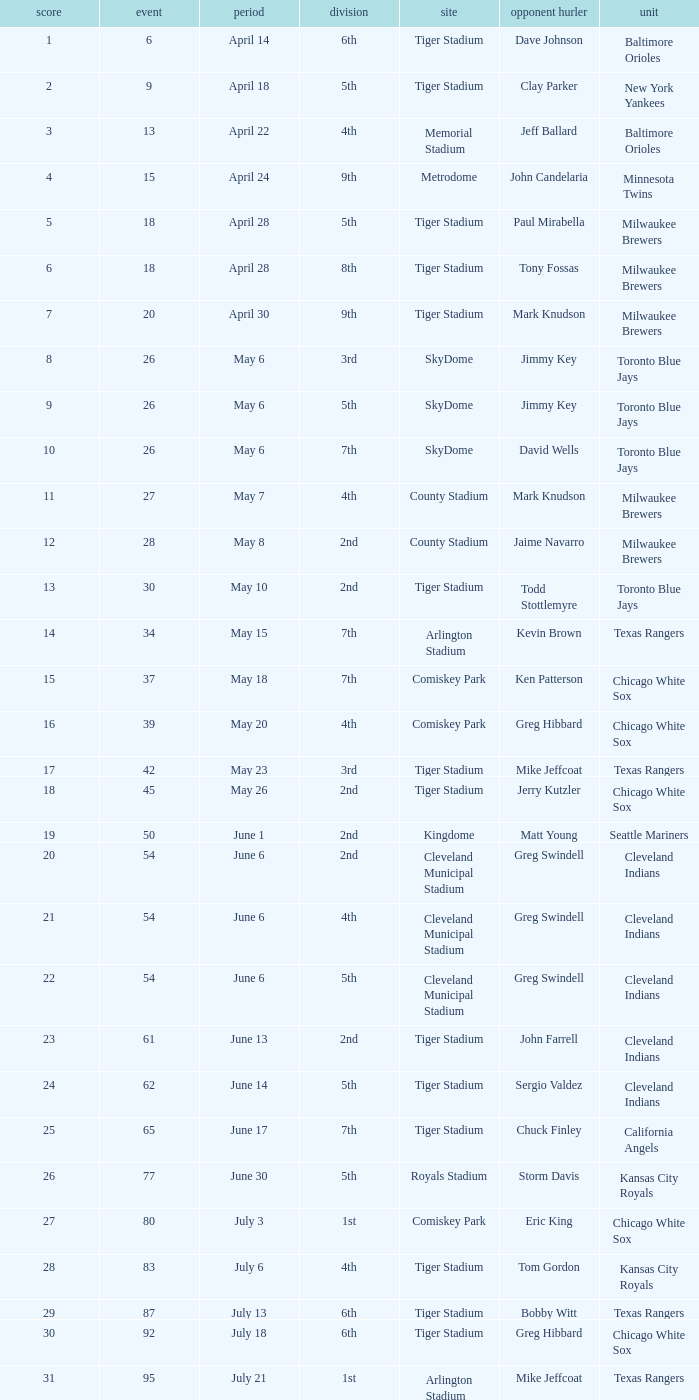Would you be able to parse every entry in this table? {'header': ['score', 'event', 'period', 'division', 'site', 'opponent hurler', 'unit'], 'rows': [['1', '6', 'April 14', '6th', 'Tiger Stadium', 'Dave Johnson', 'Baltimore Orioles'], ['2', '9', 'April 18', '5th', 'Tiger Stadium', 'Clay Parker', 'New York Yankees'], ['3', '13', 'April 22', '4th', 'Memorial Stadium', 'Jeff Ballard', 'Baltimore Orioles'], ['4', '15', 'April 24', '9th', 'Metrodome', 'John Candelaria', 'Minnesota Twins'], ['5', '18', 'April 28', '5th', 'Tiger Stadium', 'Paul Mirabella', 'Milwaukee Brewers'], ['6', '18', 'April 28', '8th', 'Tiger Stadium', 'Tony Fossas', 'Milwaukee Brewers'], ['7', '20', 'April 30', '9th', 'Tiger Stadium', 'Mark Knudson', 'Milwaukee Brewers'], ['8', '26', 'May 6', '3rd', 'SkyDome', 'Jimmy Key', 'Toronto Blue Jays'], ['9', '26', 'May 6', '5th', 'SkyDome', 'Jimmy Key', 'Toronto Blue Jays'], ['10', '26', 'May 6', '7th', 'SkyDome', 'David Wells', 'Toronto Blue Jays'], ['11', '27', 'May 7', '4th', 'County Stadium', 'Mark Knudson', 'Milwaukee Brewers'], ['12', '28', 'May 8', '2nd', 'County Stadium', 'Jaime Navarro', 'Milwaukee Brewers'], ['13', '30', 'May 10', '2nd', 'Tiger Stadium', 'Todd Stottlemyre', 'Toronto Blue Jays'], ['14', '34', 'May 15', '7th', 'Arlington Stadium', 'Kevin Brown', 'Texas Rangers'], ['15', '37', 'May 18', '7th', 'Comiskey Park', 'Ken Patterson', 'Chicago White Sox'], ['16', '39', 'May 20', '4th', 'Comiskey Park', 'Greg Hibbard', 'Chicago White Sox'], ['17', '42', 'May 23', '3rd', 'Tiger Stadium', 'Mike Jeffcoat', 'Texas Rangers'], ['18', '45', 'May 26', '2nd', 'Tiger Stadium', 'Jerry Kutzler', 'Chicago White Sox'], ['19', '50', 'June 1', '2nd', 'Kingdome', 'Matt Young', 'Seattle Mariners'], ['20', '54', 'June 6', '2nd', 'Cleveland Municipal Stadium', 'Greg Swindell', 'Cleveland Indians'], ['21', '54', 'June 6', '4th', 'Cleveland Municipal Stadium', 'Greg Swindell', 'Cleveland Indians'], ['22', '54', 'June 6', '5th', 'Cleveland Municipal Stadium', 'Greg Swindell', 'Cleveland Indians'], ['23', '61', 'June 13', '2nd', 'Tiger Stadium', 'John Farrell', 'Cleveland Indians'], ['24', '62', 'June 14', '5th', 'Tiger Stadium', 'Sergio Valdez', 'Cleveland Indians'], ['25', '65', 'June 17', '7th', 'Tiger Stadium', 'Chuck Finley', 'California Angels'], ['26', '77', 'June 30', '5th', 'Royals Stadium', 'Storm Davis', 'Kansas City Royals'], ['27', '80', 'July 3', '1st', 'Comiskey Park', 'Eric King', 'Chicago White Sox'], ['28', '83', 'July 6', '4th', 'Tiger Stadium', 'Tom Gordon', 'Kansas City Royals'], ['29', '87', 'July 13', '6th', 'Tiger Stadium', 'Bobby Witt', 'Texas Rangers'], ['30', '92', 'July 18', '6th', 'Tiger Stadium', 'Greg Hibbard', 'Chicago White Sox'], ['31', '95', 'July 21', '1st', 'Arlington Stadium', 'Mike Jeffcoat', 'Texas Rangers'], ['32', '98', 'July 24', '3rd', 'Tiger Stadium', 'John Mitchell', 'Baltimore Orioles'], ['33', '104', 'July 30', '4th', 'Yankee Stadium', 'Dave LaPoint', 'New York Yankees'], ['34', '108', 'August 3', '2nd', 'Fenway Park', 'Greg Harris', 'Boston Red Sox'], ['35', '111', 'August 7', '9th', 'Skydome', 'Jimmy Key', 'Toronto Blue Jays'], ['36', '117', 'August 13', '1st', 'Cleveland Stadium', 'Jeff Shaw', 'Cleveland Indians'], ['37', '120', 'August 16', '3rd', 'Tiger Stadium', 'Ron Robinson', 'Milwaukee Brewers'], ['38', '121', 'August 17', '6th', 'Tiger Stadium', 'Tom Candiotti', 'Cleveland Indians'], ['39', '122', 'August 18', '3rd', 'Tiger Stadium', 'Efrain Valdez', 'Cleveland Indians'], ['40', '127', 'August 25', '1st', 'Tiger Stadium', 'Dave Stewart', 'Oakland Athletics'], ['41', '127', 'August 25', '4th', 'Tiger Stadium', 'Dave Stewart', 'Oakland Athletics'], ['42', '130', 'August 29', '8th', 'Kingdome', 'Matt Young', 'Seattle Mariners'], ['43', '135', 'September 3', '6th', 'Tiger Stadium', 'Jimmy Key', 'Toronto Blue Jays'], ['44', '137', 'September 5', '6th', 'Tiger Stadium', 'David Wells', 'Toronto Blue Jays'], ['45', '139', 'September 7', '6th', 'County Stadium', 'Ted Higuera', 'Milwaukee Brewers'], ['46', '145', 'September 13', '9th', 'Tiger Stadium', 'Mike Witt', 'New York Yankees'], ['47', '148', 'September 16', '5th', 'Tiger Stadium', 'Mark Leiter', 'New York Yankees'], ['48', '153', 'September 23', '2nd', 'Oakland Coliseum', 'Mike Moore', 'Oakland Athletics'], ['49', '156', 'September 27', '8th', 'Tiger Stadium', 'Dennis Lamp', 'Boston Red Sox'], ['50', '162', 'October 3', '4th', 'Yankee Stadium', 'Steve Adkins', 'New York Yankees'], ['51', '162', 'October 3', '8th', 'Yankee Stadium', 'Alan Mills', 'New York Yankees']]} When Efrain Valdez was pitching, what was the highest home run? 39.0. 